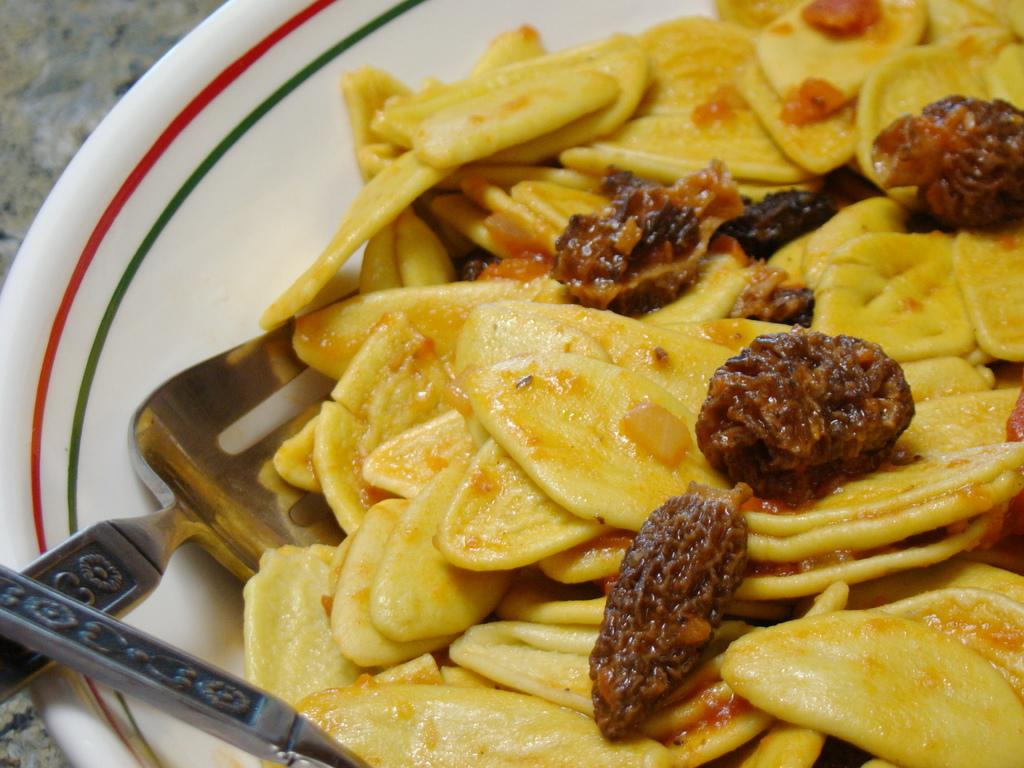What type of objects can be seen in the image? There are food items and two forks in the image. How are the food items and forks arranged? They are arranged on a white color plate. What can be observed about the background of the image? The background of the image is blurred. Can you tell me how many buttons are on the crow in the image? There is no crow or button present in the image. What type of bee can be seen buzzing around the food items in the image? There is no bee present in the image; the food items and forks are arranged on a plate. 